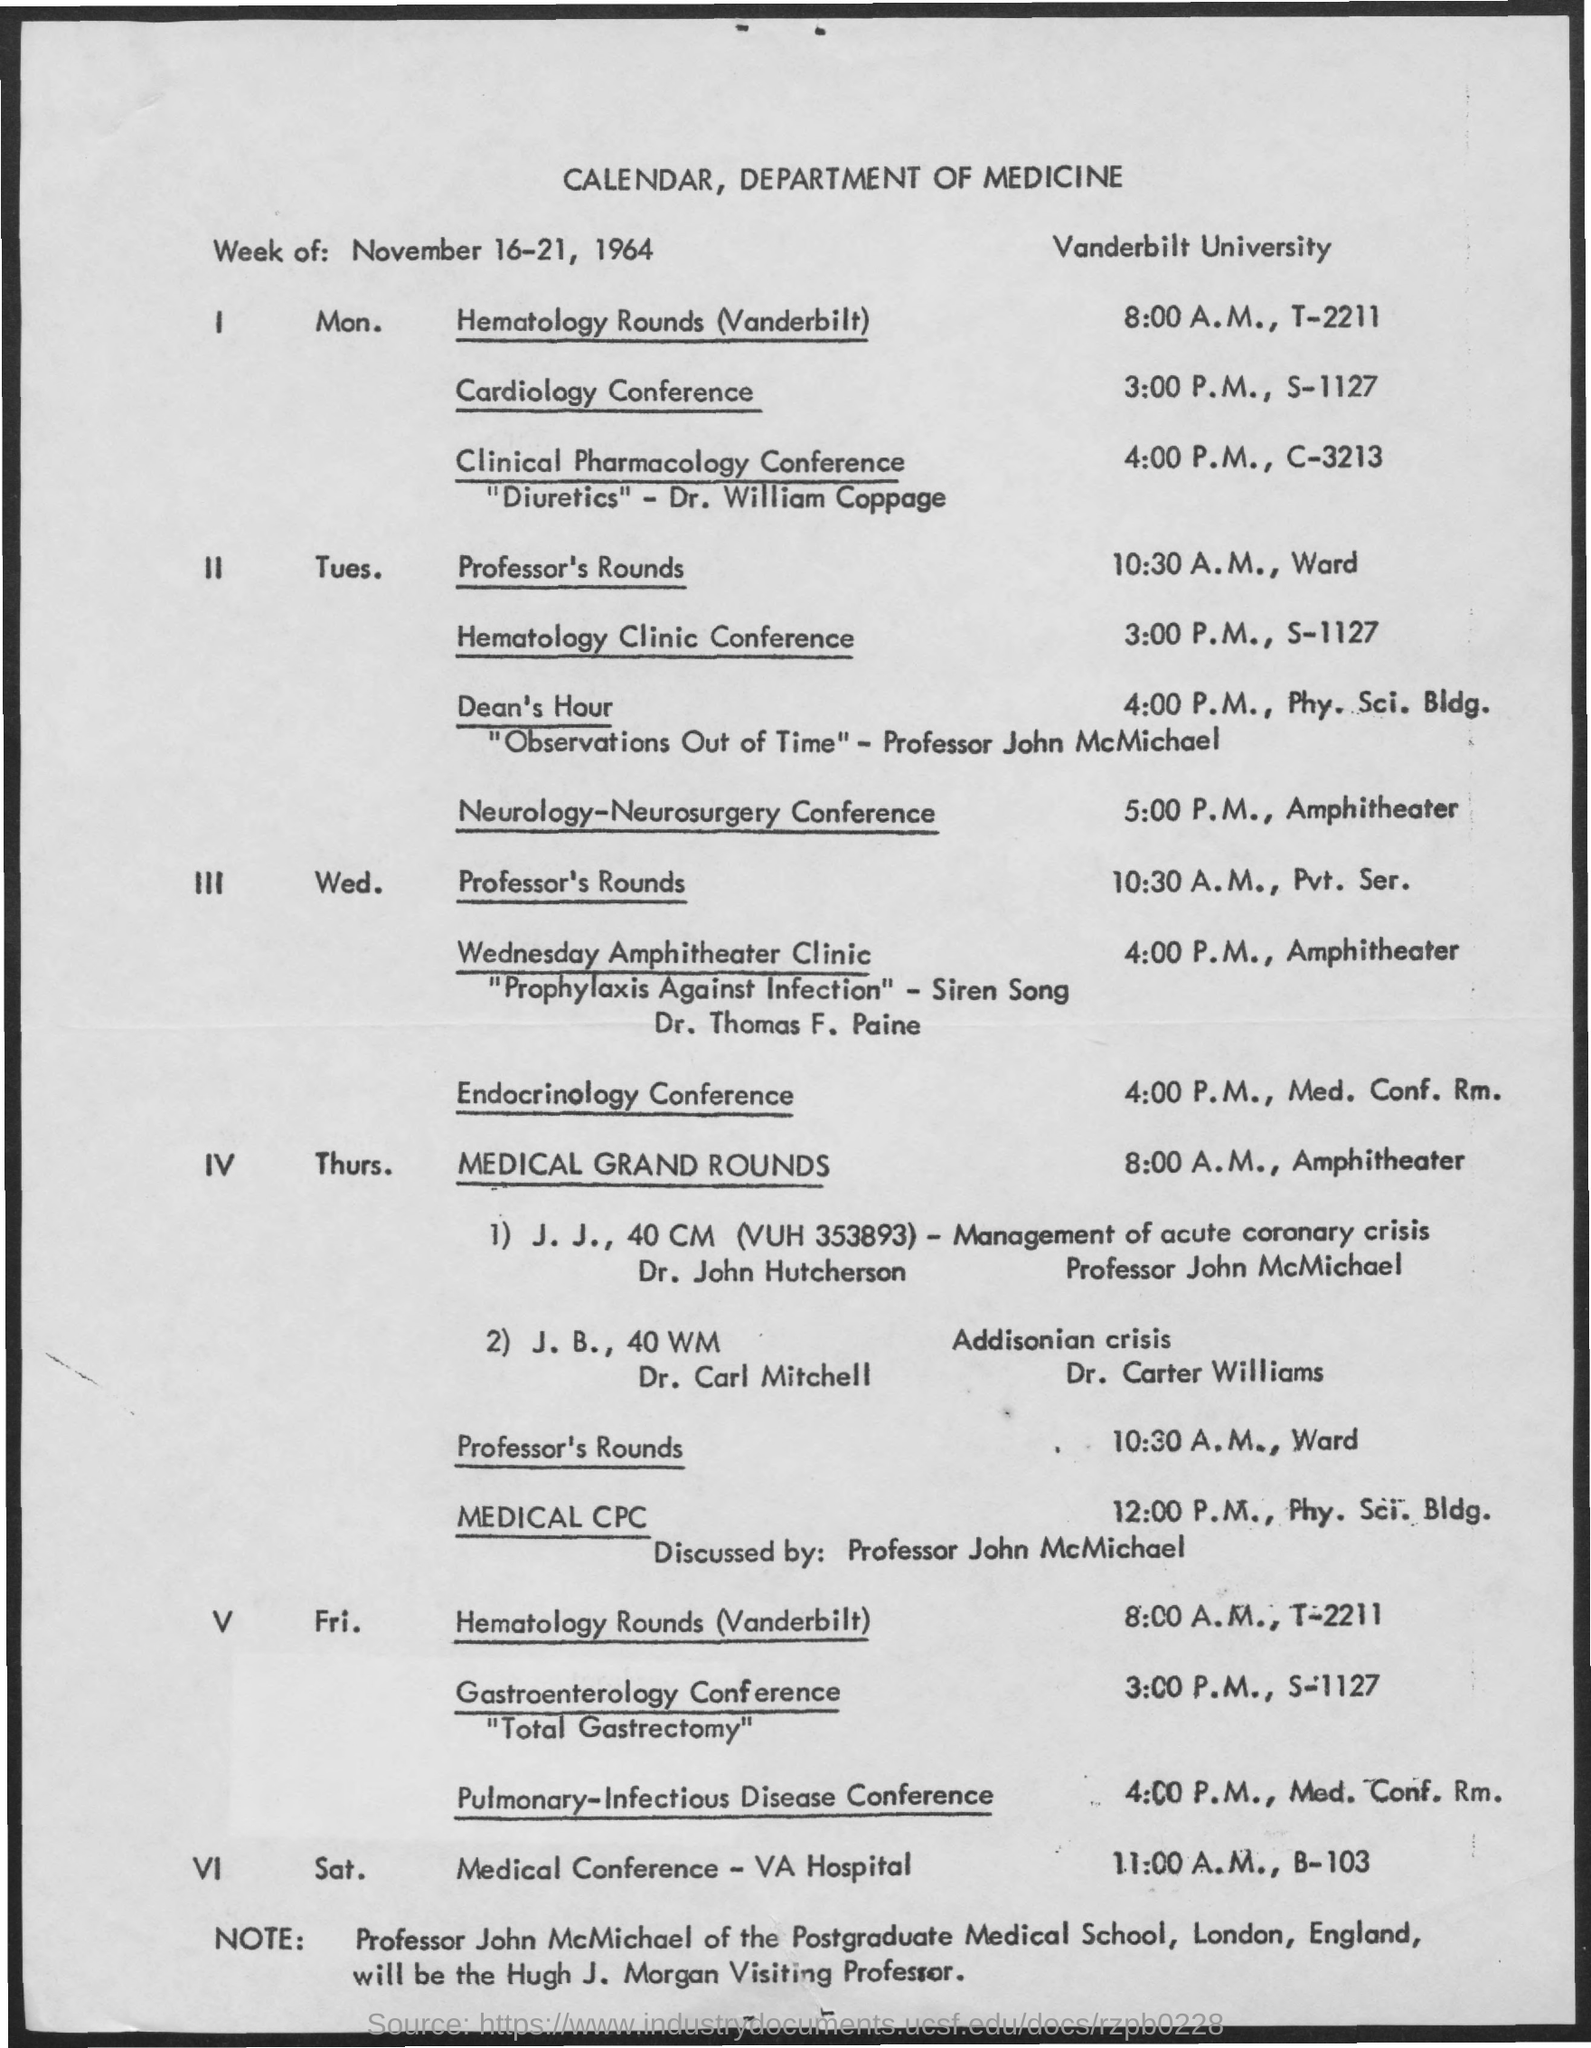Highlight a few significant elements in this photo. The heading of the document at the top is "Calendar," with the Department of Medicine listed below it. Medical CPC is a topic that is discussed by Professor John McMichael. 